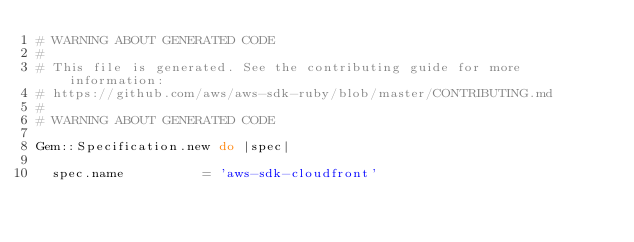<code> <loc_0><loc_0><loc_500><loc_500><_Ruby_># WARNING ABOUT GENERATED CODE
#
# This file is generated. See the contributing guide for more information:
# https://github.com/aws/aws-sdk-ruby/blob/master/CONTRIBUTING.md
#
# WARNING ABOUT GENERATED CODE

Gem::Specification.new do |spec|

  spec.name          = 'aws-sdk-cloudfront'</code> 